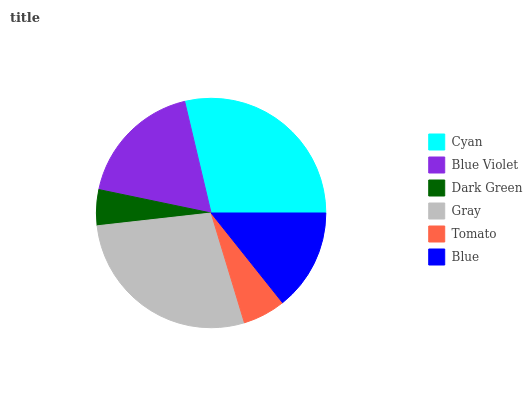Is Dark Green the minimum?
Answer yes or no. Yes. Is Cyan the maximum?
Answer yes or no. Yes. Is Blue Violet the minimum?
Answer yes or no. No. Is Blue Violet the maximum?
Answer yes or no. No. Is Cyan greater than Blue Violet?
Answer yes or no. Yes. Is Blue Violet less than Cyan?
Answer yes or no. Yes. Is Blue Violet greater than Cyan?
Answer yes or no. No. Is Cyan less than Blue Violet?
Answer yes or no. No. Is Blue Violet the high median?
Answer yes or no. Yes. Is Blue the low median?
Answer yes or no. Yes. Is Cyan the high median?
Answer yes or no. No. Is Tomato the low median?
Answer yes or no. No. 